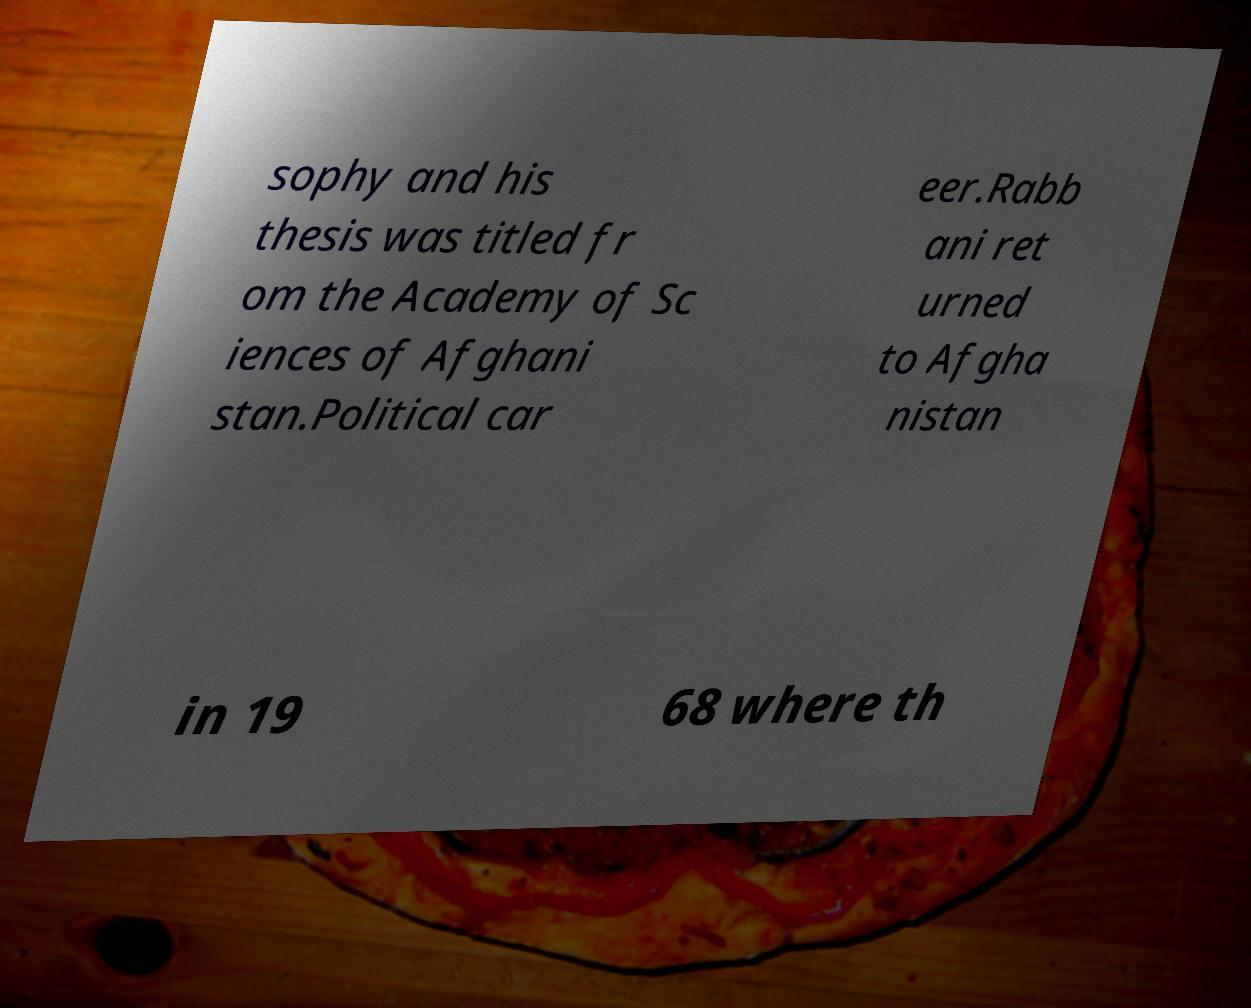Could you extract and type out the text from this image? sophy and his thesis was titled fr om the Academy of Sc iences of Afghani stan.Political car eer.Rabb ani ret urned to Afgha nistan in 19 68 where th 